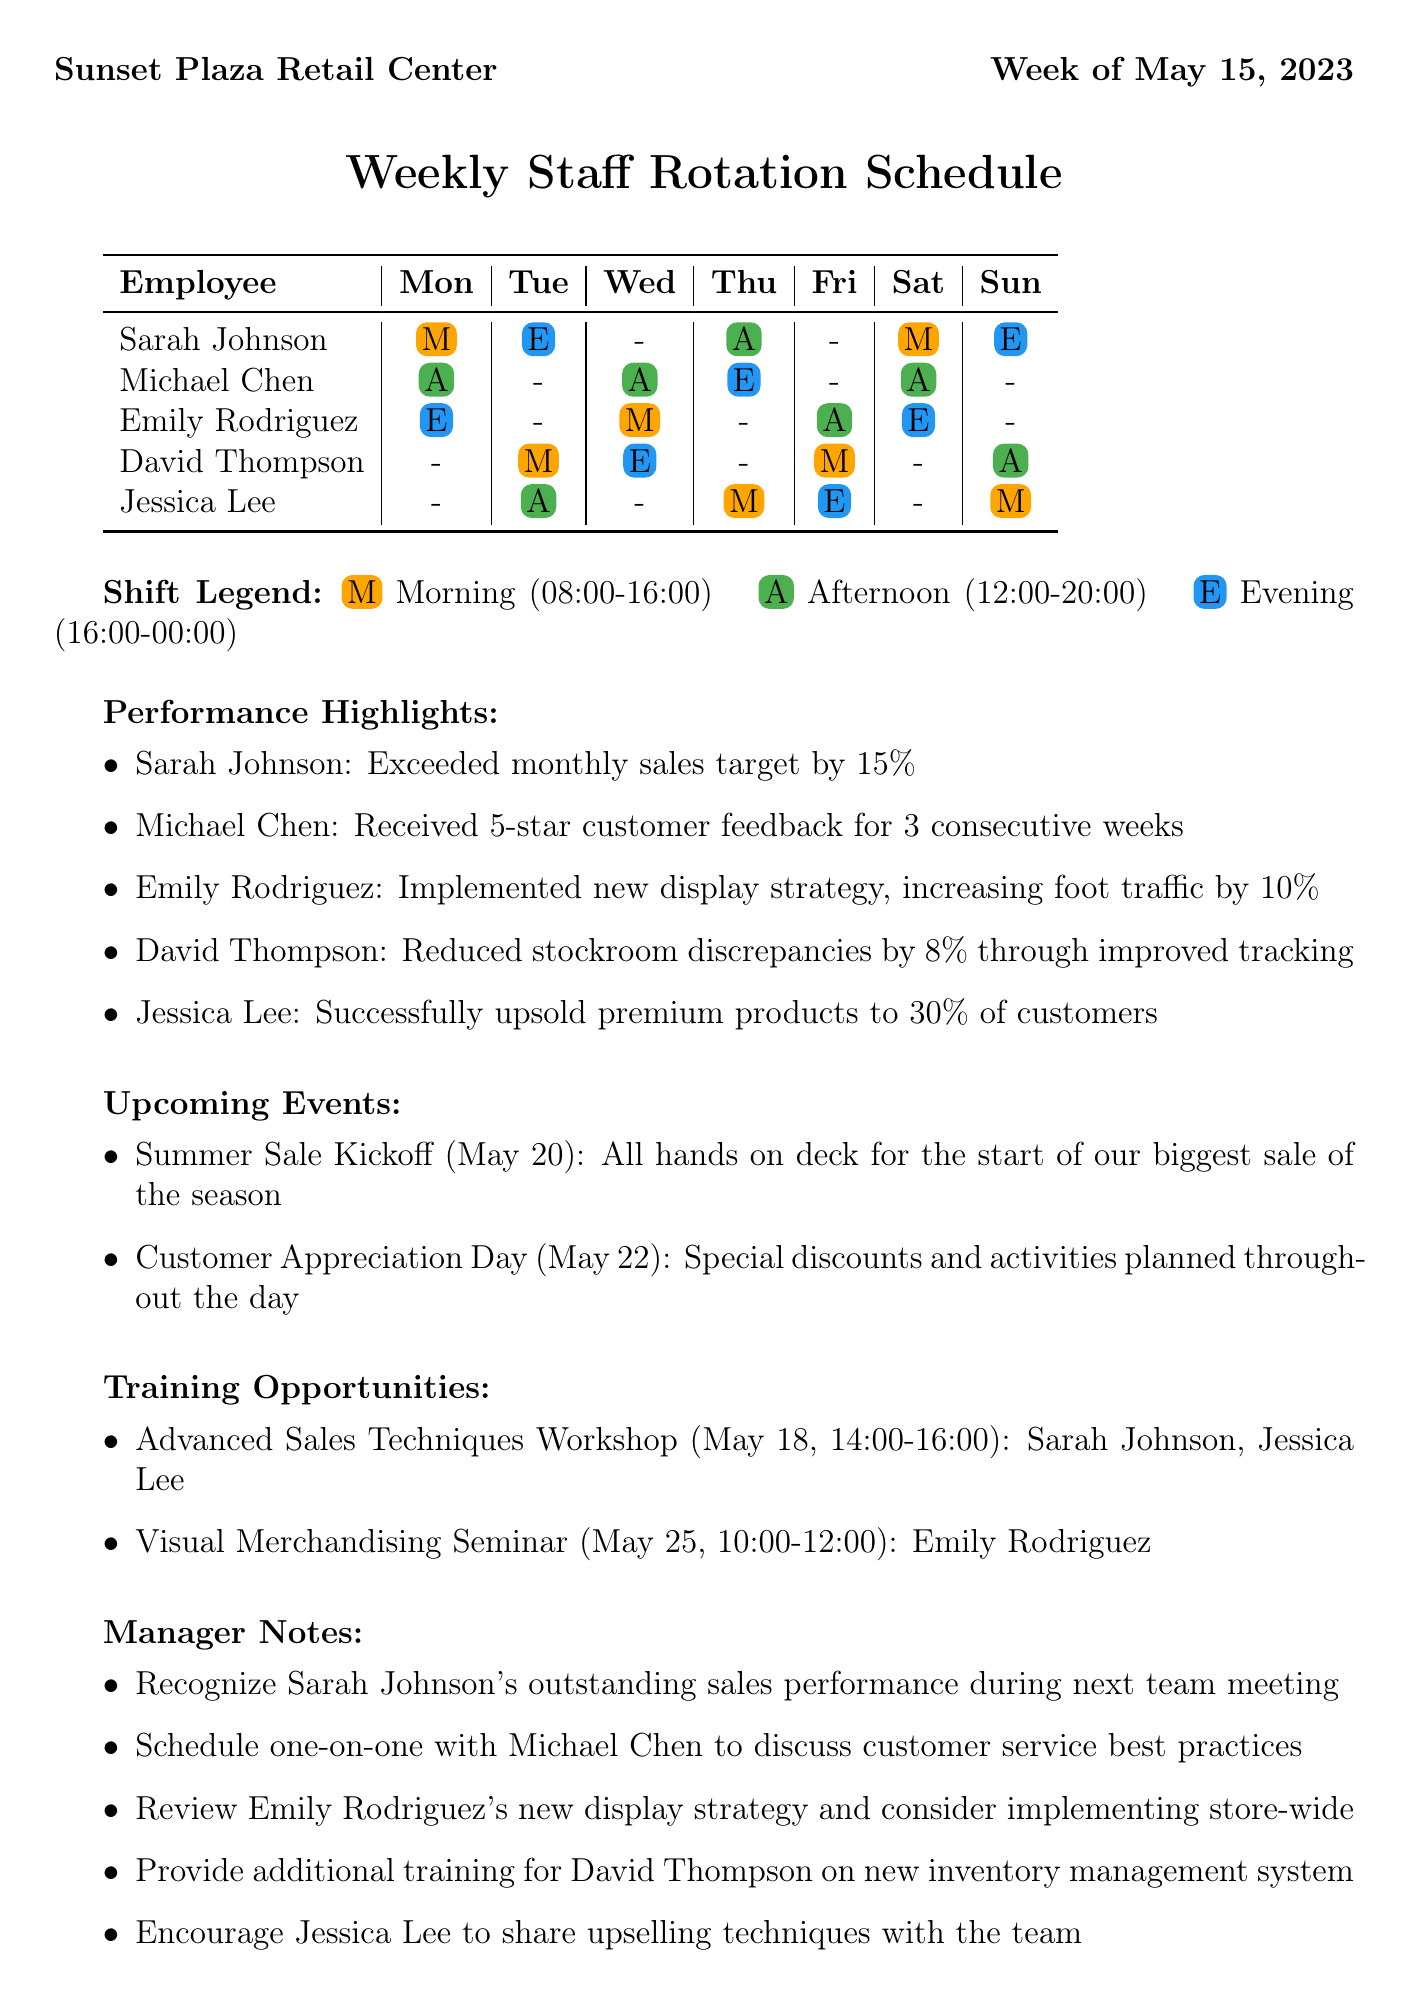What is the name of the store? The store's name is explicitly mentioned at the beginning of the document as "Sunset Plaza Retail Center."
Answer: Sunset Plaza Retail Center Who received 5-star customer feedback? This refers to Michael Chen's performance highlight, which states he received 5-star customer feedback for 3 consecutive weeks.
Answer: Michael Chen What shift does Sarah Johnson work on Wednesday? The document indicates that Sarah has no assignment for Wednesday, marked with a dash.
Answer: - How many employees are eligible for the Advanced Sales Techniques Workshop? The document lists Sarah Johnson and Jessica Lee as eligible for this workshop.
Answer: 2 On what date is the Customer Appreciation Day scheduled? This specific upcoming event is noted to take place on May 22, 2023.
Answer: May 22 Which employee implemented a new display strategy? The performance highlight section attributes this achievement to Emily Rodriguez.
Answer: Emily Rodriguez What is the color code for the Afternoon shift? The document defines the color code associated with the Afternoon shift in the shift legend as #4CAF50.
Answer: #4CAF50 What is the total number of training opportunities listed? The document lists two training opportunities in the training opportunities section.
Answer: 2 Who is scheduled for the Evening shift on Saturday? According to the weekly schedule, Emily Rodriguez is assigned to the Evening shift on Saturday.
Answer: Emily Rodriguez 